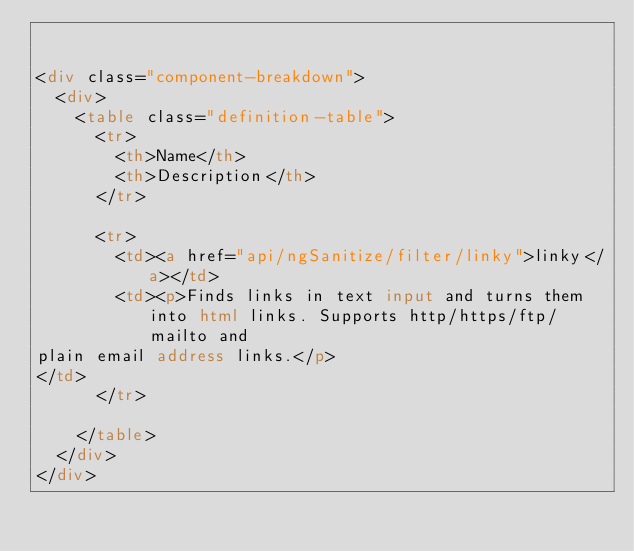<code> <loc_0><loc_0><loc_500><loc_500><_HTML_>

<div class="component-breakdown">
  <div>
    <table class="definition-table">
      <tr>
        <th>Name</th>
        <th>Description</th>
      </tr>
      
      <tr>
        <td><a href="api/ngSanitize/filter/linky">linky</a></td>
        <td><p>Finds links in text input and turns them into html links. Supports http/https/ftp/mailto and
plain email address links.</p>
</td>
      </tr>
      
    </table>
  </div>
</div>

</code> 